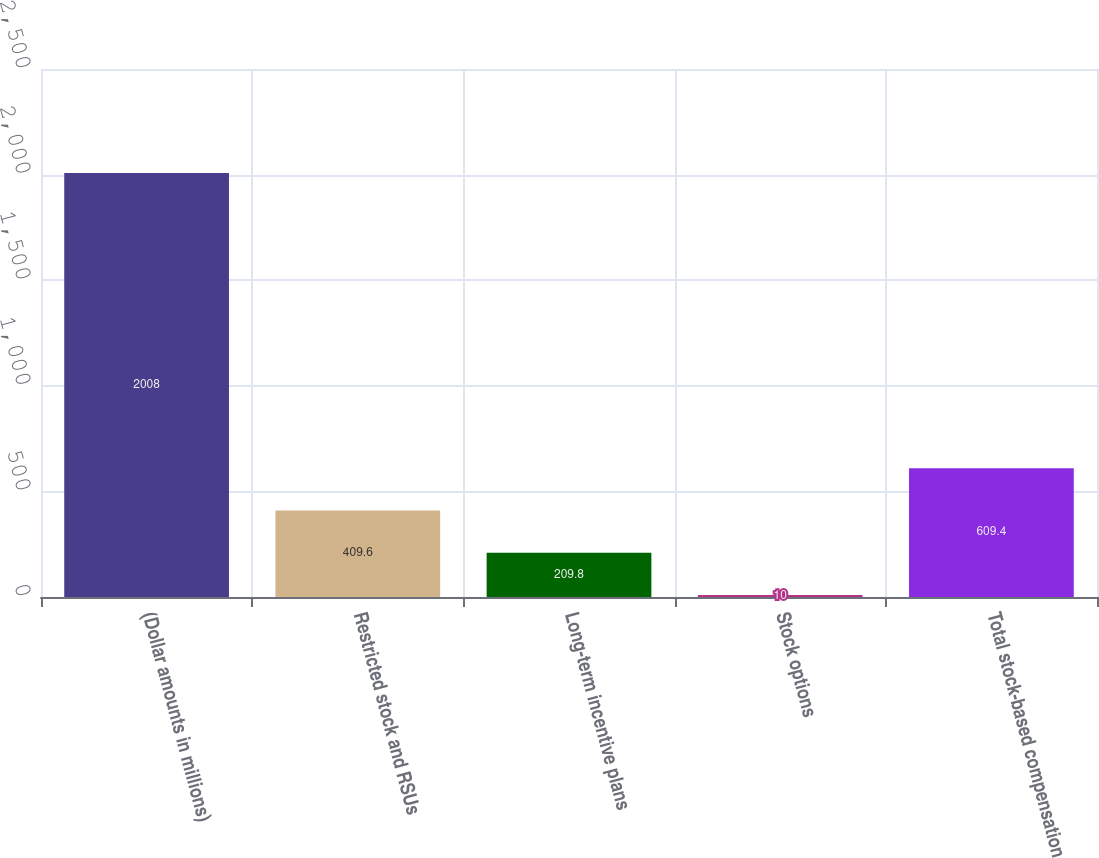Convert chart to OTSL. <chart><loc_0><loc_0><loc_500><loc_500><bar_chart><fcel>(Dollar amounts in millions)<fcel>Restricted stock and RSUs<fcel>Long-term incentive plans<fcel>Stock options<fcel>Total stock-based compensation<nl><fcel>2008<fcel>409.6<fcel>209.8<fcel>10<fcel>609.4<nl></chart> 